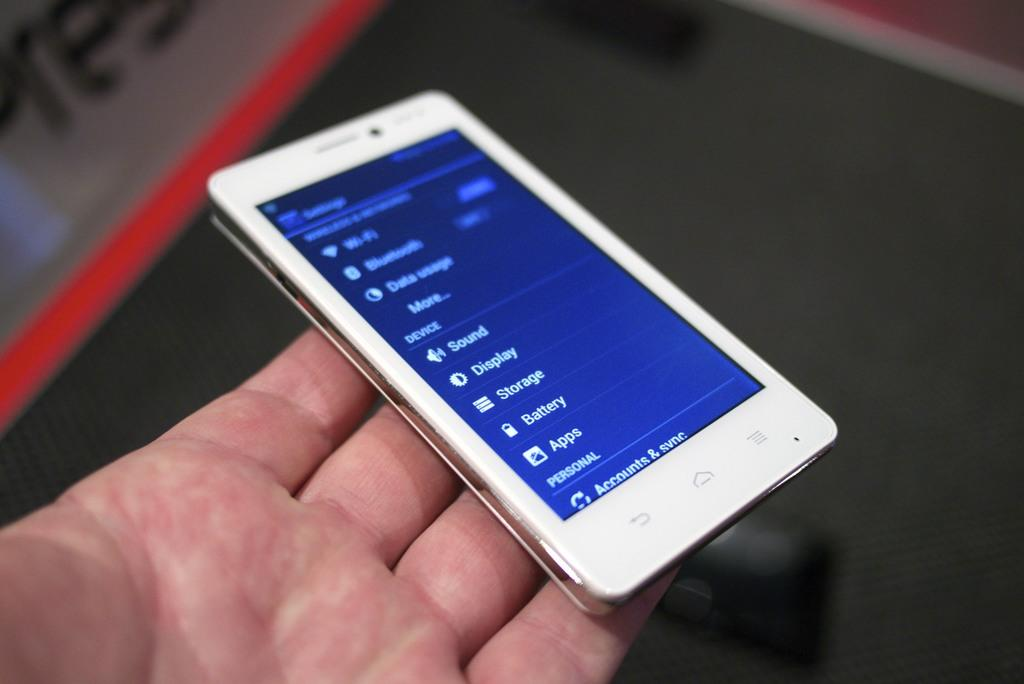Provide a one-sentence caption for the provided image. A phone is being held with the screen displaying settings such as sound, display, storeage, battery, and apps. 